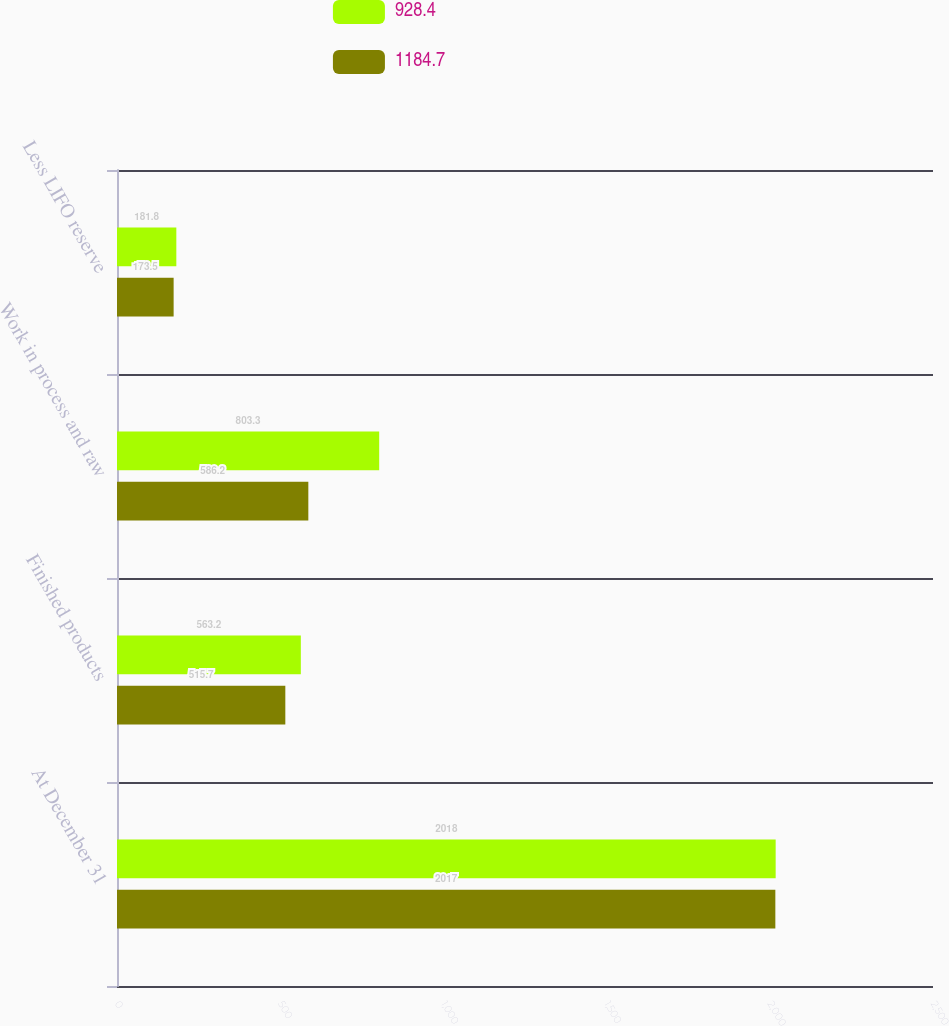Convert chart to OTSL. <chart><loc_0><loc_0><loc_500><loc_500><stacked_bar_chart><ecel><fcel>At December 31<fcel>Finished products<fcel>Work in process and raw<fcel>Less LIFO reserve<nl><fcel>928.4<fcel>2018<fcel>563.2<fcel>803.3<fcel>181.8<nl><fcel>1184.7<fcel>2017<fcel>515.7<fcel>586.2<fcel>173.5<nl></chart> 